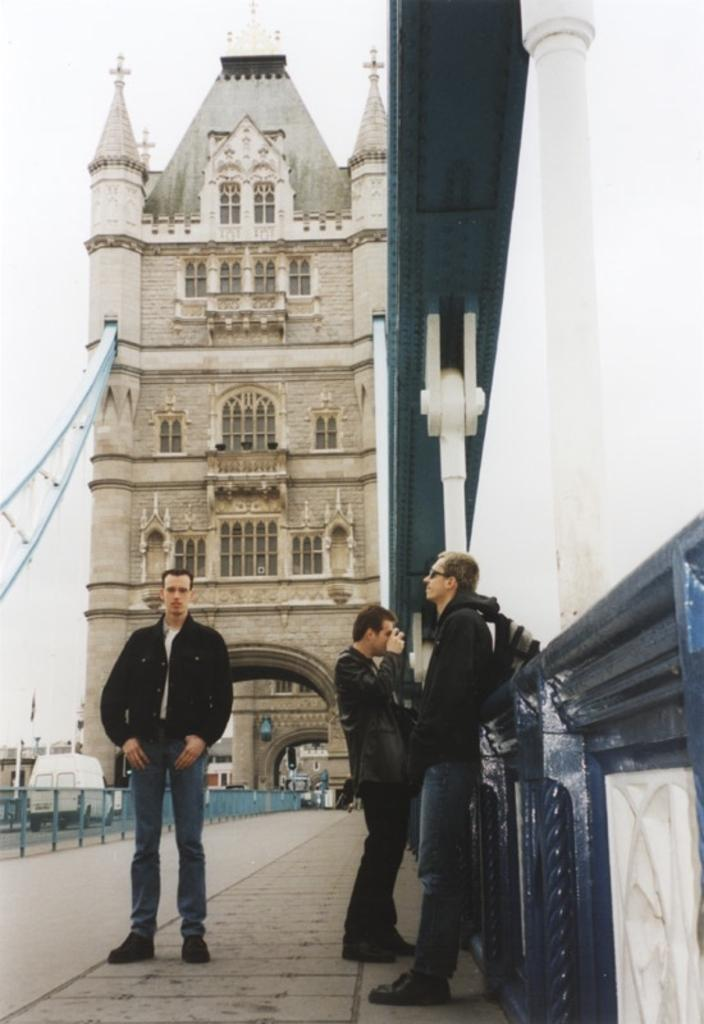How many men are standing on the platform in the image? There are three men standing on the platform in the image. What else can be seen on the road in the image? There is a vehicle on the road. What type of barrier is present in the image? There is a fence in the image. What type of structures are visible in the image? There are buildings with windows in the image. What is visible in the background of the image? The sky is visible in the background of the image. Can you tell me how many eggs are being carried by the girl in the image? There is no girl present in the image, and therefore no eggs being carried. What type of engine is visible in the image? There is no engine visible in the image. 